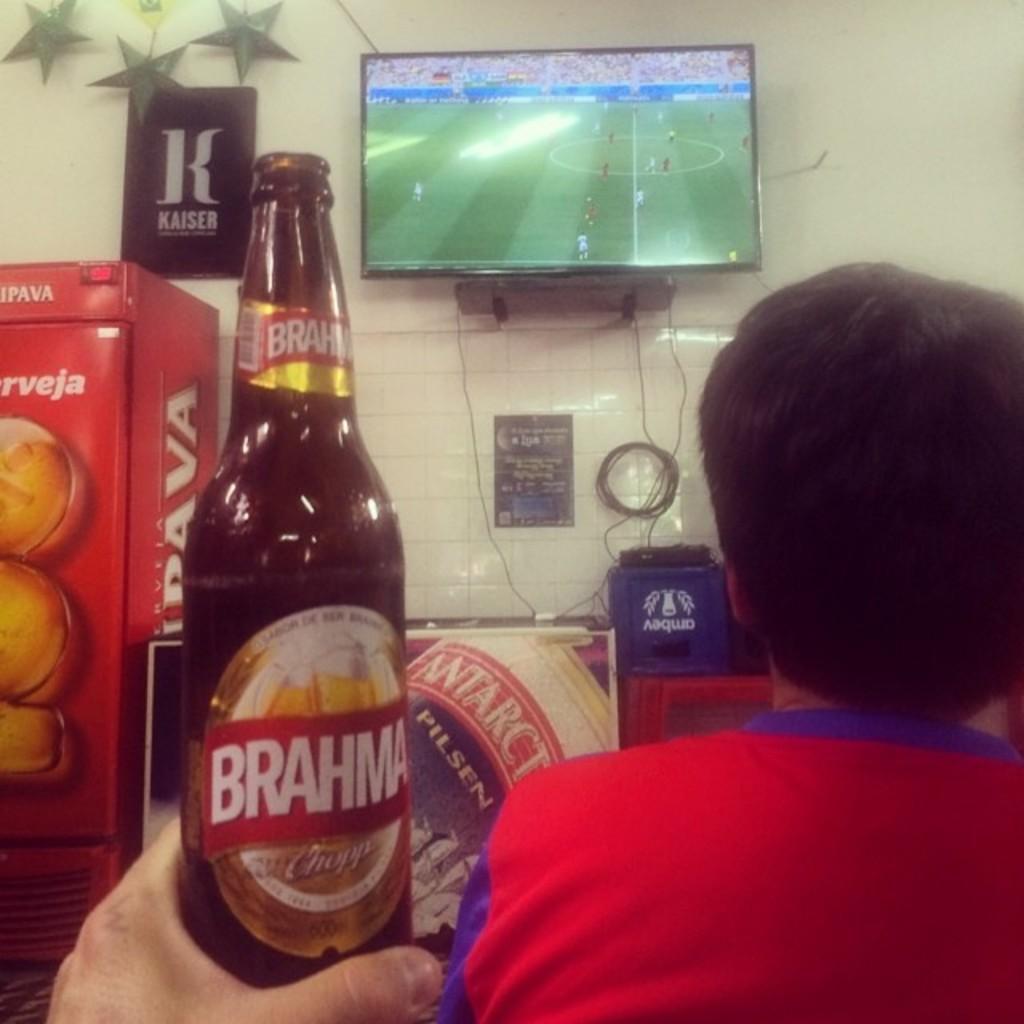Please provide a concise description of this image. In this picture there is a person holding a bottle. There is a man ,Television, poster. 